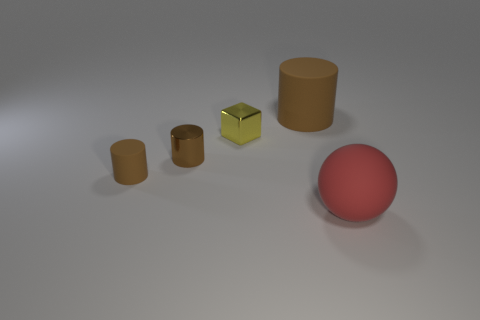Is the size of the cylinder behind the metallic block the same as the tiny yellow block?
Provide a succinct answer. No. Is there a purple thing that has the same material as the big red object?
Make the answer very short. No. What number of things are big objects to the left of the red thing or large cyan shiny objects?
Your answer should be very brief. 1. Are any small metallic cylinders visible?
Ensure brevity in your answer.  Yes. What is the shape of the thing that is on the right side of the yellow shiny thing and behind the large red ball?
Give a very brief answer. Cylinder. How big is the brown object that is to the left of the brown metal cylinder?
Provide a succinct answer. Small. There is a rubber cylinder to the left of the large brown rubber cylinder; is its color the same as the ball?
Keep it short and to the point. No. How many other brown things are the same shape as the tiny brown matte thing?
Provide a succinct answer. 2. How many objects are small metallic objects that are behind the metal cylinder or big things behind the sphere?
Provide a short and direct response. 2. What number of red things are small shiny objects or rubber balls?
Your answer should be compact. 1. 